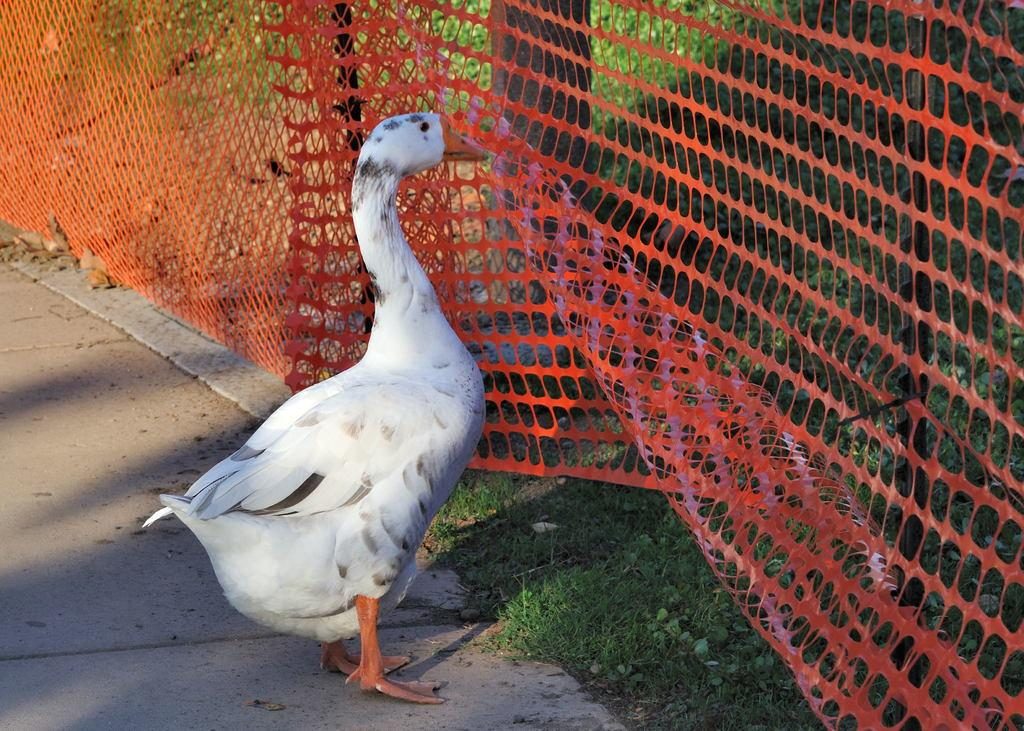What animal is present in the image? There is a duck in the image. What is the duck's position in relation to the ground? The duck is standing on the ground. What is in front of the duck? There is red color fencing in front of the duck. What type of vegetation can be seen in the image? There is grass visible in the image. What is located at the top of the image? There is a tree at the top of the image. What type of science experiment can be seen being conducted with the duck in the image? There is no science experiment or any indication of one being conducted in the image. 